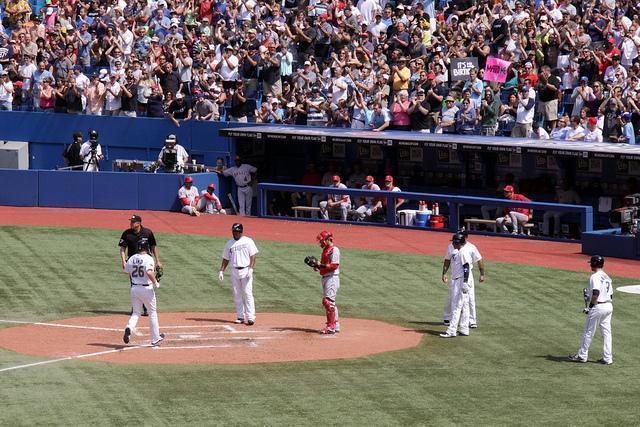What position is the man in red kneepads on the field playing?
Answer the question by selecting the correct answer among the 4 following choices.
Options: Catcher, umpire, outfielder, first base. Catcher. 